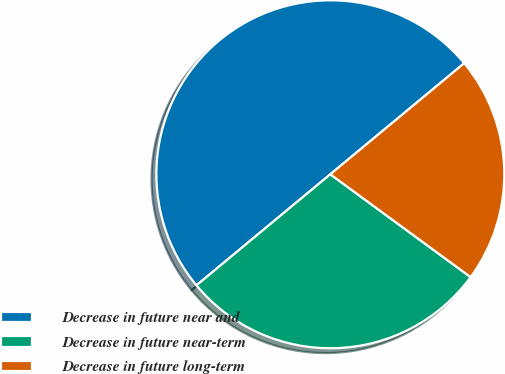<chart> <loc_0><loc_0><loc_500><loc_500><pie_chart><fcel>Decrease in future near and<fcel>Decrease in future near-term<fcel>Decrease in future long-term<nl><fcel>50.0%<fcel>28.91%<fcel>21.09%<nl></chart> 